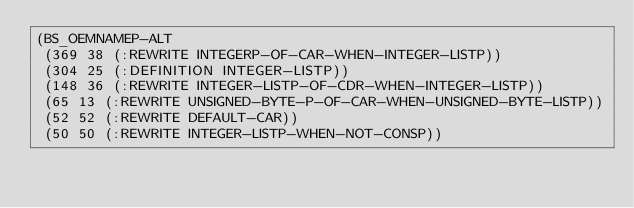Convert code to text. <code><loc_0><loc_0><loc_500><loc_500><_Lisp_>(BS_OEMNAMEP-ALT
 (369 38 (:REWRITE INTEGERP-OF-CAR-WHEN-INTEGER-LISTP))
 (304 25 (:DEFINITION INTEGER-LISTP))
 (148 36 (:REWRITE INTEGER-LISTP-OF-CDR-WHEN-INTEGER-LISTP))
 (65 13 (:REWRITE UNSIGNED-BYTE-P-OF-CAR-WHEN-UNSIGNED-BYTE-LISTP))
 (52 52 (:REWRITE DEFAULT-CAR))
 (50 50 (:REWRITE INTEGER-LISTP-WHEN-NOT-CONSP))</code> 